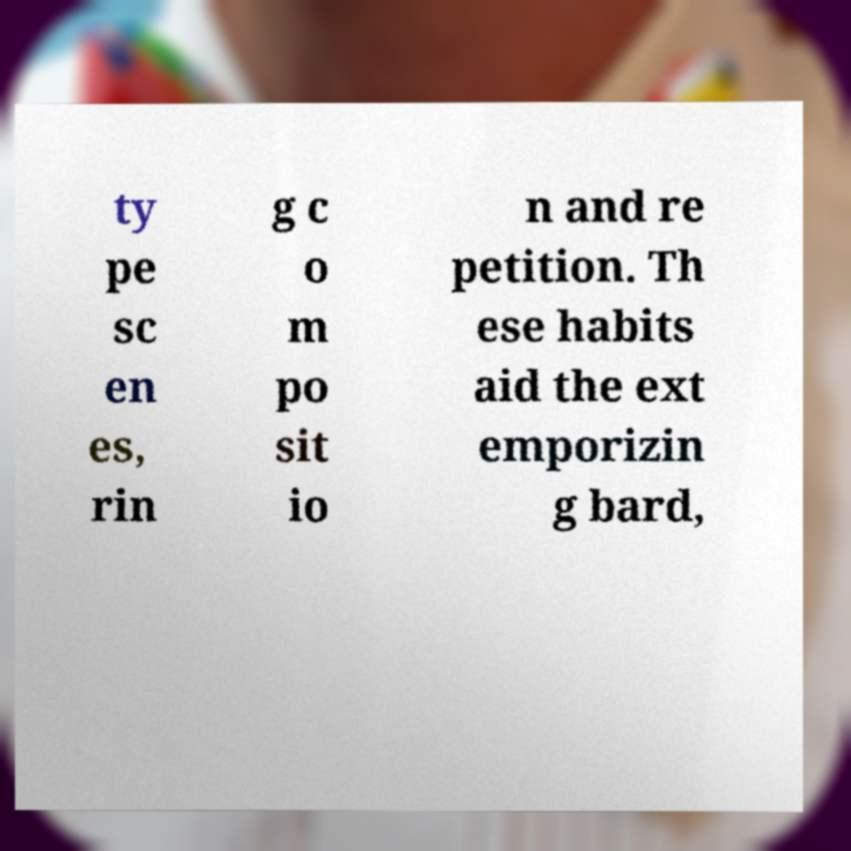Please identify and transcribe the text found in this image. ty pe sc en es, rin g c o m po sit io n and re petition. Th ese habits aid the ext emporizin g bard, 